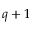Convert formula to latex. <formula><loc_0><loc_0><loc_500><loc_500>q + 1</formula> 